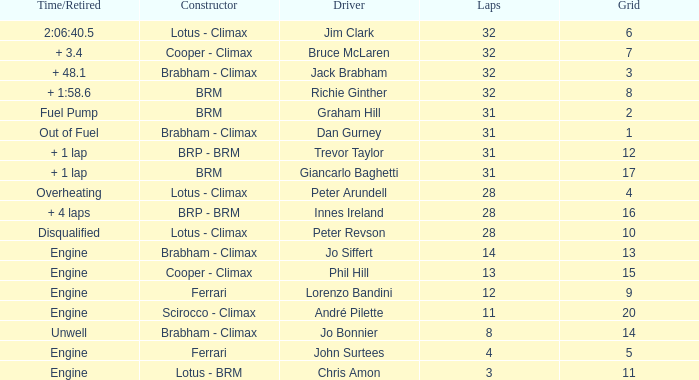What is the average grid for jack brabham going over 32 laps? None. 